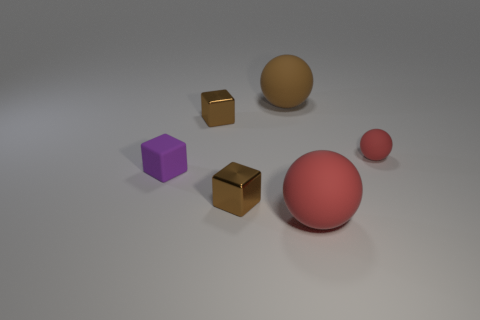Add 4 yellow matte spheres. How many objects exist? 10 Add 4 matte objects. How many matte objects are left? 8 Add 1 large red matte balls. How many large red matte balls exist? 2 Subtract 0 blue blocks. How many objects are left? 6 Subtract all purple blocks. Subtract all purple objects. How many objects are left? 4 